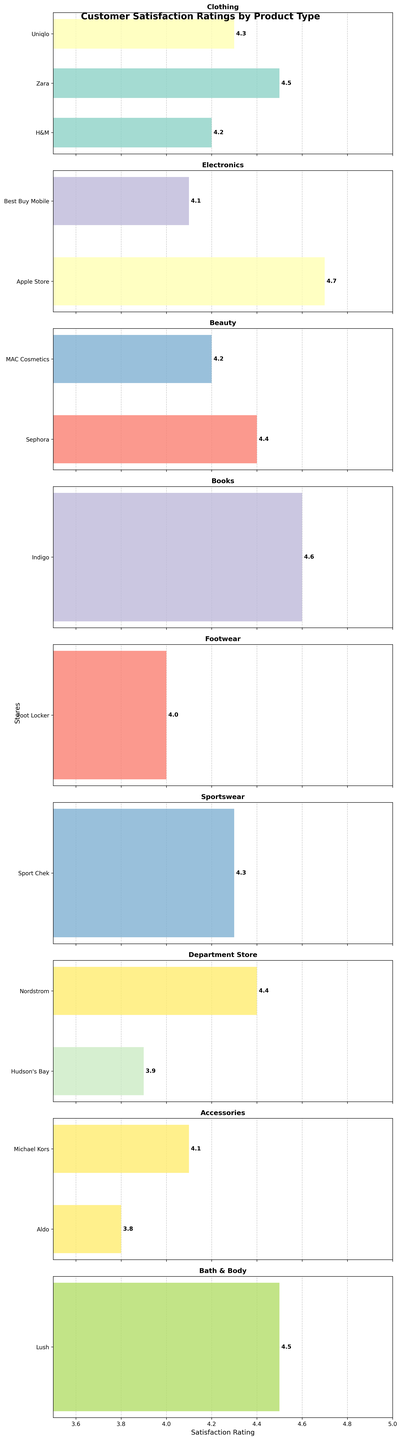What's the highest customer satisfaction rating for Electronics stores? The subplot for Electronics stores shows that the Apple Store has the highest rating at 4.7.
Answer: 4.7 How many stores are there under the Beauty product type? The subplot for Beauty indicates there are two stores: Sephora and MAC Cosmetics.
Answer: 2 Which store has a higher customer satisfaction rating: Nordstrom or Hudson’s Bay? The Department Store subplot shows Nordstrom at 4.4 and Hudson’s Bay at 3.9. Therefore, Nordstrom is higher.
Answer: Nordstrom What's the average customer satisfaction rating for Clothing stores? The Clothing subplot has ratings of H&M at 4.2, Zara at 4.5, and Uniqlo at 4.3. The average is (4.2 + 4.5 + 4.3) / 3 = 4.33.
Answer: 4.33 Which product type has the store with the lowest customer satisfaction rating? The Accessories subplot indicates Aldo has the lowest rating at 3.8.
Answer: Accessories Compare the satisfaction ratings between Foot Locker and Sport Chek. The Footwear and Sportswear subplots show ratings of 4.0 for Foot Locker and 4.3 for Sport Chek; hence, Sport Chek has a higher rating.
Answer: Sport Chek Is there any store under Bath & Body product type? By looking at all subplots, there is one store, Lush, under the Bath & Body category with a rating of 4.5.
Answer: Yes What is the difference in satisfaction ratings between Indigo and Apple Store? The Books subplot shows Indigo at 4.6 and the Electronics subplot shows Apple Store at 4.7, giving a difference of 4.7 - 4.6 = 0.1.
Answer: 0.1 Which store has a better rating: Best Buy Mobile or Michael Kors? The Electronics subplot shows Best Buy Mobile at 4.1, and the Accessories subplot shows Michael Kors at 4.1. Both are equal.
Answer: Equal What is the median satisfaction rating for the Department Store product type? The Department Store subplot has ratings of 3.9 and 4.4. The median is the middle value between the two, which is (3.9 + 4.4)/2 = 4.15.
Answer: 4.15 